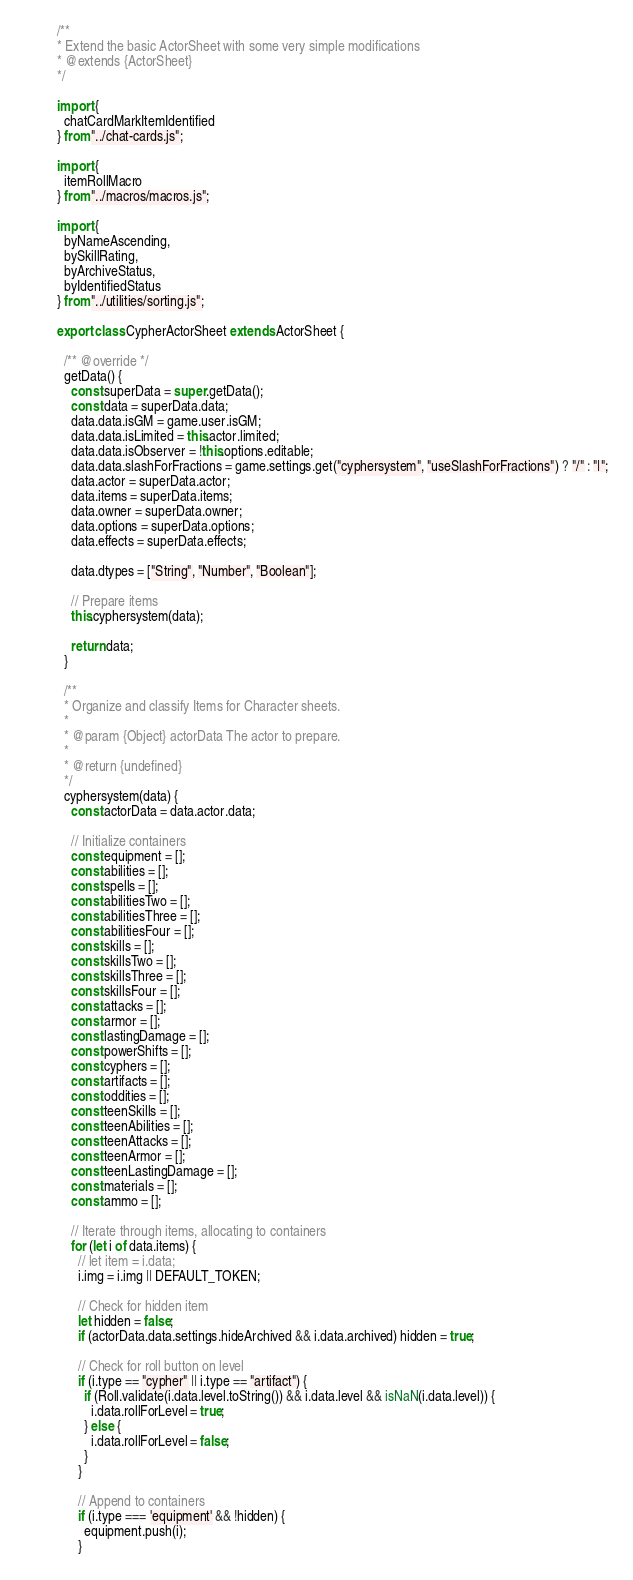Convert code to text. <code><loc_0><loc_0><loc_500><loc_500><_JavaScript_>/**
* Extend the basic ActorSheet with some very simple modifications
* @extends {ActorSheet}
*/

import {
  chatCardMarkItemIdentified
} from "../chat-cards.js";

import {
  itemRollMacro
} from "../macros/macros.js";

import {
  byNameAscending,
  bySkillRating,
  byArchiveStatus,
  byIdentifiedStatus
} from "../utilities/sorting.js";

export class CypherActorSheet extends ActorSheet {

  /** @override */
  getData() {
    const superData = super.getData();
    const data = superData.data;
    data.data.isGM = game.user.isGM;
    data.data.isLimited = this.actor.limited;
    data.data.isObserver = !this.options.editable;
    data.data.slashForFractions = game.settings.get("cyphersystem", "useSlashForFractions") ? "/" : "|";
    data.actor = superData.actor;
    data.items = superData.items;
    data.owner = superData.owner;
    data.options = superData.options;
    data.effects = superData.effects;

    data.dtypes = ["String", "Number", "Boolean"];

    // Prepare items
    this.cyphersystem(data);

    return data;
  }

  /**
  * Organize and classify Items for Character sheets.
  *
  * @param {Object} actorData The actor to prepare.
  *
  * @return {undefined}
  */
  cyphersystem(data) {
    const actorData = data.actor.data;

    // Initialize containers
    const equipment = [];
    const abilities = [];
    const spells = [];
    const abilitiesTwo = [];
    const abilitiesThree = [];
    const abilitiesFour = [];
    const skills = [];
    const skillsTwo = [];
    const skillsThree = [];
    const skillsFour = [];
    const attacks = [];
    const armor = [];
    const lastingDamage = [];
    const powerShifts = [];
    const cyphers = [];
    const artifacts = [];
    const oddities = [];
    const teenSkills = [];
    const teenAbilities = [];
    const teenAttacks = [];
    const teenArmor = [];
    const teenLastingDamage = [];
    const materials = [];
    const ammo = [];

    // Iterate through items, allocating to containers
    for (let i of data.items) {
      // let item = i.data;
      i.img = i.img || DEFAULT_TOKEN;

      // Check for hidden item
      let hidden = false;
      if (actorData.data.settings.hideArchived && i.data.archived) hidden = true;

      // Check for roll button on level
      if (i.type == "cypher" || i.type == "artifact") {
        if (Roll.validate(i.data.level.toString()) && i.data.level && isNaN(i.data.level)) {
          i.data.rollForLevel = true;
        } else {
          i.data.rollForLevel = false;
        }
      }

      // Append to containers
      if (i.type === 'equipment' && !hidden) {
        equipment.push(i);
      }</code> 